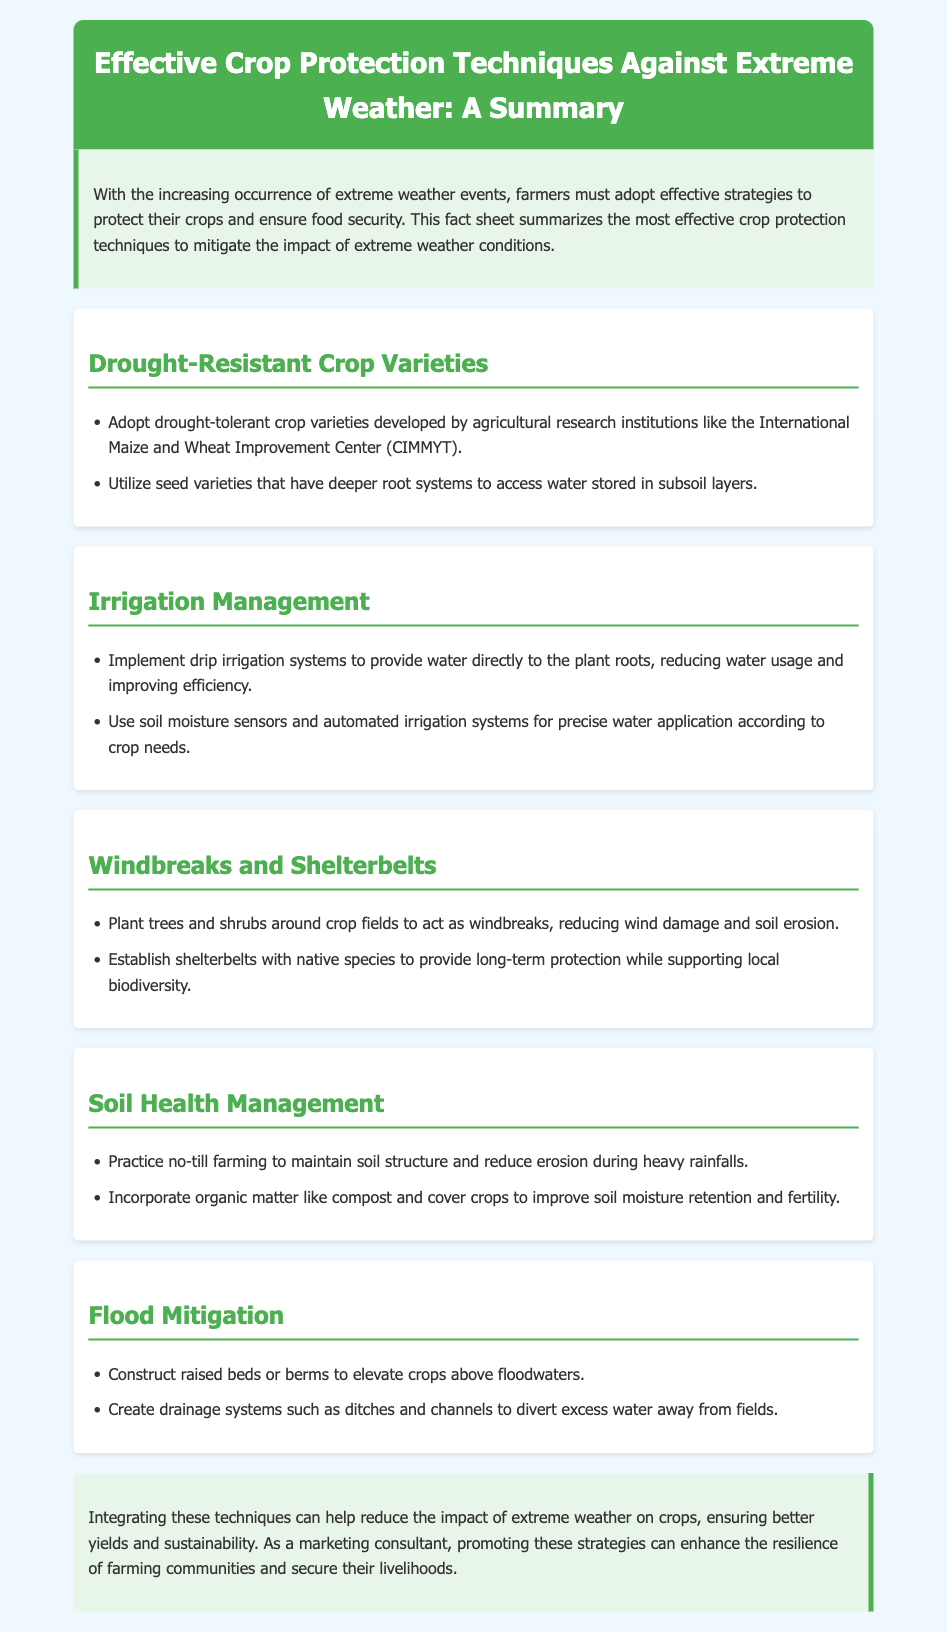What is the title of the document? The title is presented in the header section of the document, which summarizes the main topic.
Answer: Effective Crop Protection Techniques Against Extreme Weather: A Summary What does the introduction highlight? The introduction outlines the importance of adopting strategies to protect crops from extreme weather, ensuring food security.
Answer: The increasing occurrence of extreme weather events Which crop management technique uses soil moisture sensors? This technique is mentioned in the Irrigation Management section, emphasizing modern methods for precise water application.
Answer: Automated irrigation systems What type of trees are suggested for windbreaks? The recommendation is found in the Windbreaks and Shelterbelts section, focusing on biodiversity alongside crop protection.
Answer: Native species What is one benefit of no-till farming? This is stated in the Soil Health Management section, discussing practices that maintain soil structure.
Answer: Reduce erosion How can farmers mitigate flood impact on crops? Several strategies are outlined in the Flood Mitigation section, focusing on elevating crops above potential floodwaters.
Answer: Construct raised beds What are the two drought-resistant crop variety strategies mentioned? These strategies are provided in the Drought-Resistant Crop Varieties section, describing developments in crop resilience.
Answer: Drought-tolerant crop varieties and deeper root systems What is the conclusion's primary focus? The conclusion summarizes the overall aim of integrating the discussed techniques for better agricultural resilience.
Answer: Reduce the impact of extreme weather on crops 